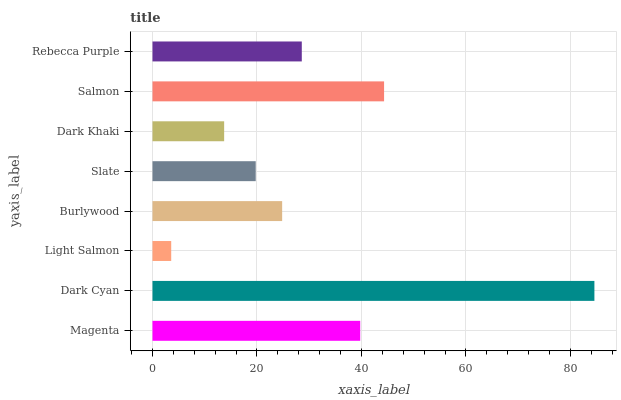Is Light Salmon the minimum?
Answer yes or no. Yes. Is Dark Cyan the maximum?
Answer yes or no. Yes. Is Dark Cyan the minimum?
Answer yes or no. No. Is Light Salmon the maximum?
Answer yes or no. No. Is Dark Cyan greater than Light Salmon?
Answer yes or no. Yes. Is Light Salmon less than Dark Cyan?
Answer yes or no. Yes. Is Light Salmon greater than Dark Cyan?
Answer yes or no. No. Is Dark Cyan less than Light Salmon?
Answer yes or no. No. Is Rebecca Purple the high median?
Answer yes or no. Yes. Is Burlywood the low median?
Answer yes or no. Yes. Is Slate the high median?
Answer yes or no. No. Is Salmon the low median?
Answer yes or no. No. 